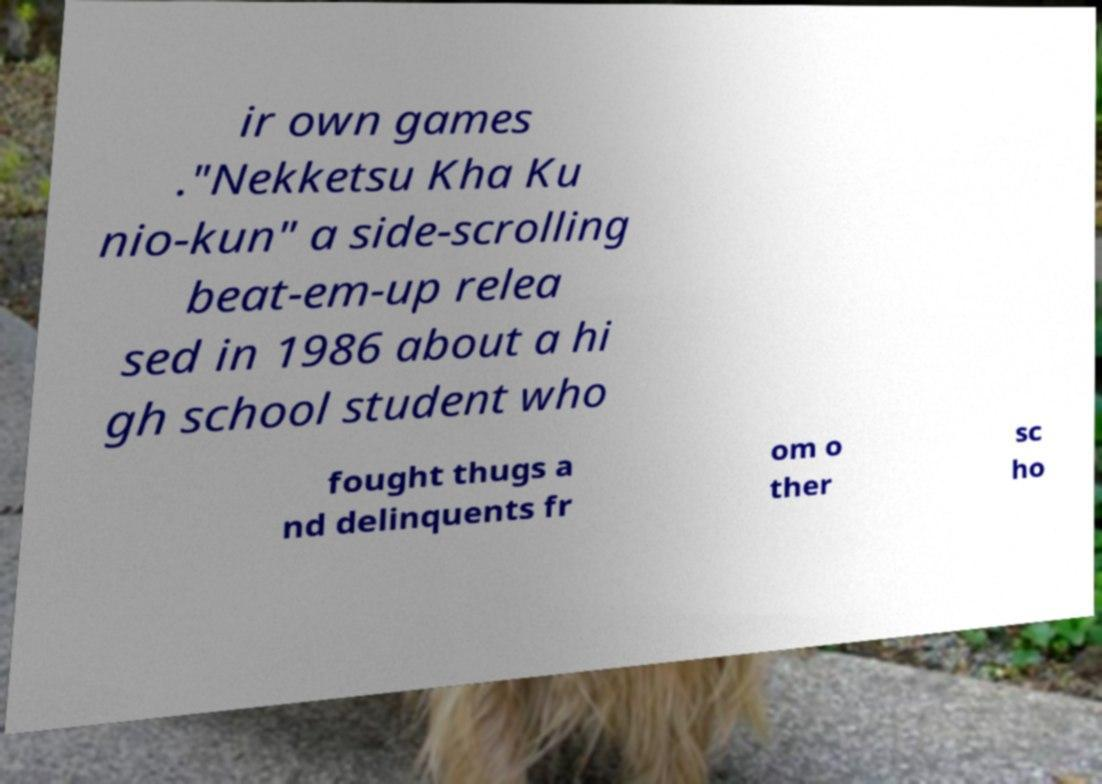What messages or text are displayed in this image? I need them in a readable, typed format. ir own games ."Nekketsu Kha Ku nio-kun" a side-scrolling beat-em-up relea sed in 1986 about a hi gh school student who fought thugs a nd delinquents fr om o ther sc ho 